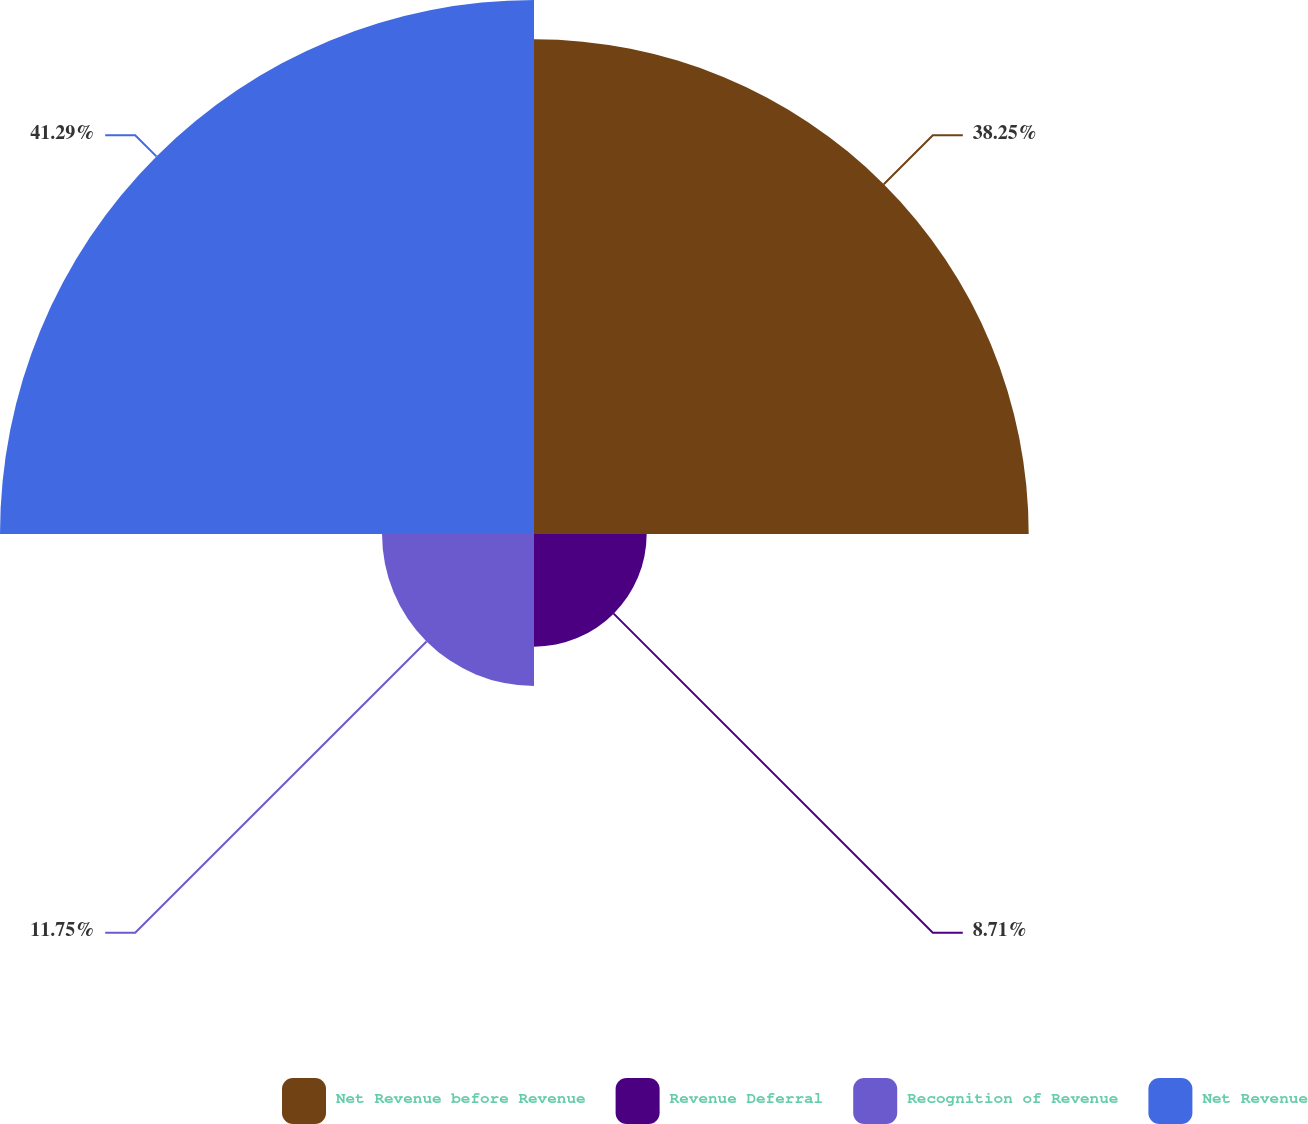Convert chart. <chart><loc_0><loc_0><loc_500><loc_500><pie_chart><fcel>Net Revenue before Revenue<fcel>Revenue Deferral<fcel>Recognition of Revenue<fcel>Net Revenue<nl><fcel>38.25%<fcel>8.71%<fcel>11.75%<fcel>41.29%<nl></chart> 